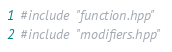Convert code to text. <code><loc_0><loc_0><loc_500><loc_500><_C++_>#include "function.hpp"
#include "modifiers.hpp"
</code> 